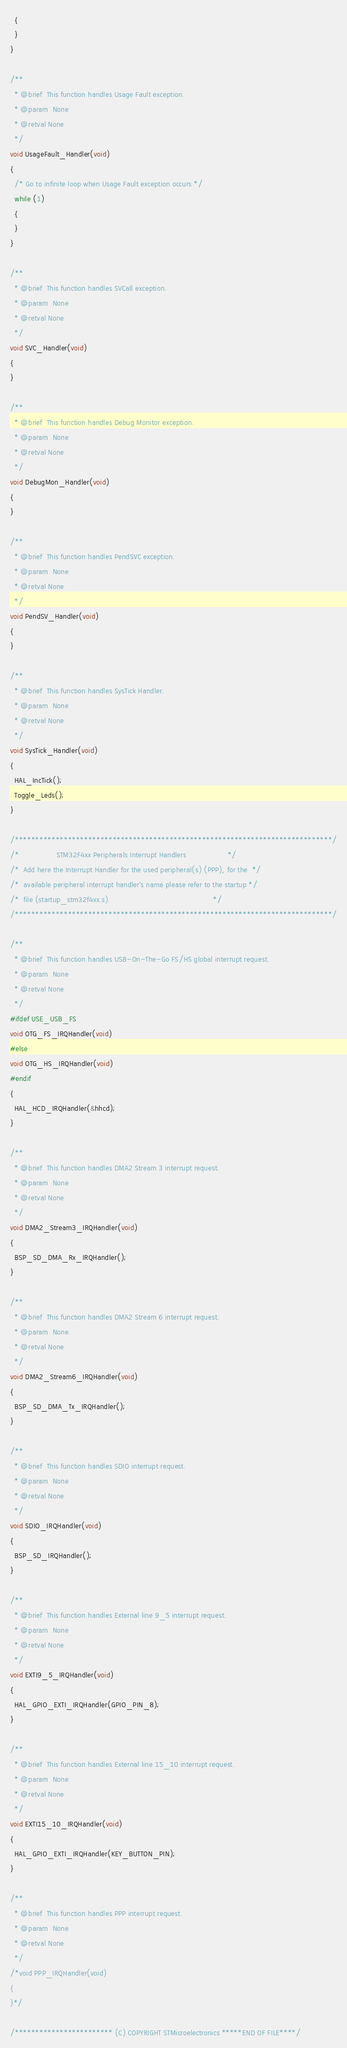<code> <loc_0><loc_0><loc_500><loc_500><_C_>  {
  }
}

/**
  * @brief  This function handles Usage Fault exception.
  * @param  None
  * @retval None
  */
void UsageFault_Handler(void)
{
  /* Go to infinite loop when Usage Fault exception occurs */
  while (1)
  {
  }
}

/**
  * @brief  This function handles SVCall exception.
  * @param  None
  * @retval None
  */
void SVC_Handler(void)
{
}

/**
  * @brief  This function handles Debug Monitor exception.
  * @param  None
  * @retval None
  */
void DebugMon_Handler(void)
{
}

/**
  * @brief  This function handles PendSVC exception.
  * @param  None
  * @retval None
  */
void PendSV_Handler(void)
{
}

/**
  * @brief  This function handles SysTick Handler.
  * @param  None
  * @retval None
  */
void SysTick_Handler(void)
{
  HAL_IncTick();
  Toggle_Leds();
}

/******************************************************************************/
/*                 STM32F4xx Peripherals Interrupt Handlers                   */
/*  Add here the Interrupt Handler for the used peripheral(s) (PPP), for the  */
/*  available peripheral interrupt handler's name please refer to the startup */
/*  file (startup_stm32f4xx.s).                                               */
/******************************************************************************/

/**
  * @brief  This function handles USB-On-The-Go FS/HS global interrupt request.
  * @param  None
  * @retval None
  */
#ifdef USE_USB_FS
void OTG_FS_IRQHandler(void)
#else
void OTG_HS_IRQHandler(void)
#endif
{
  HAL_HCD_IRQHandler(&hhcd);
}

/**
  * @brief  This function handles DMA2 Stream 3 interrupt request.
  * @param  None
  * @retval None
  */
void DMA2_Stream3_IRQHandler(void)
{
  BSP_SD_DMA_Rx_IRQHandler();
}

/**
  * @brief  This function handles DMA2 Stream 6 interrupt request.
  * @param  None
  * @retval None
  */
void DMA2_Stream6_IRQHandler(void)
{
  BSP_SD_DMA_Tx_IRQHandler(); 
}

/**
  * @brief  This function handles SDIO interrupt request.
  * @param  None
  * @retval None
  */
void SDIO_IRQHandler(void)
{
  BSP_SD_IRQHandler();
}

/**
  * @brief  This function handles External line 9_5 interrupt request.
  * @param  None
  * @retval None
  */
void EXTI9_5_IRQHandler(void)
{
  HAL_GPIO_EXTI_IRQHandler(GPIO_PIN_8);
}

/**
  * @brief  This function handles External line 15_10 interrupt request.
  * @param  None
  * @retval None
  */
void EXTI15_10_IRQHandler(void)
{
  HAL_GPIO_EXTI_IRQHandler(KEY_BUTTON_PIN);
}

/**
  * @brief  This function handles PPP interrupt request.
  * @param  None
  * @retval None
  */
/*void PPP_IRQHandler(void)
{
}*/

/************************ (C) COPYRIGHT STMicroelectronics *****END OF FILE****/
</code> 